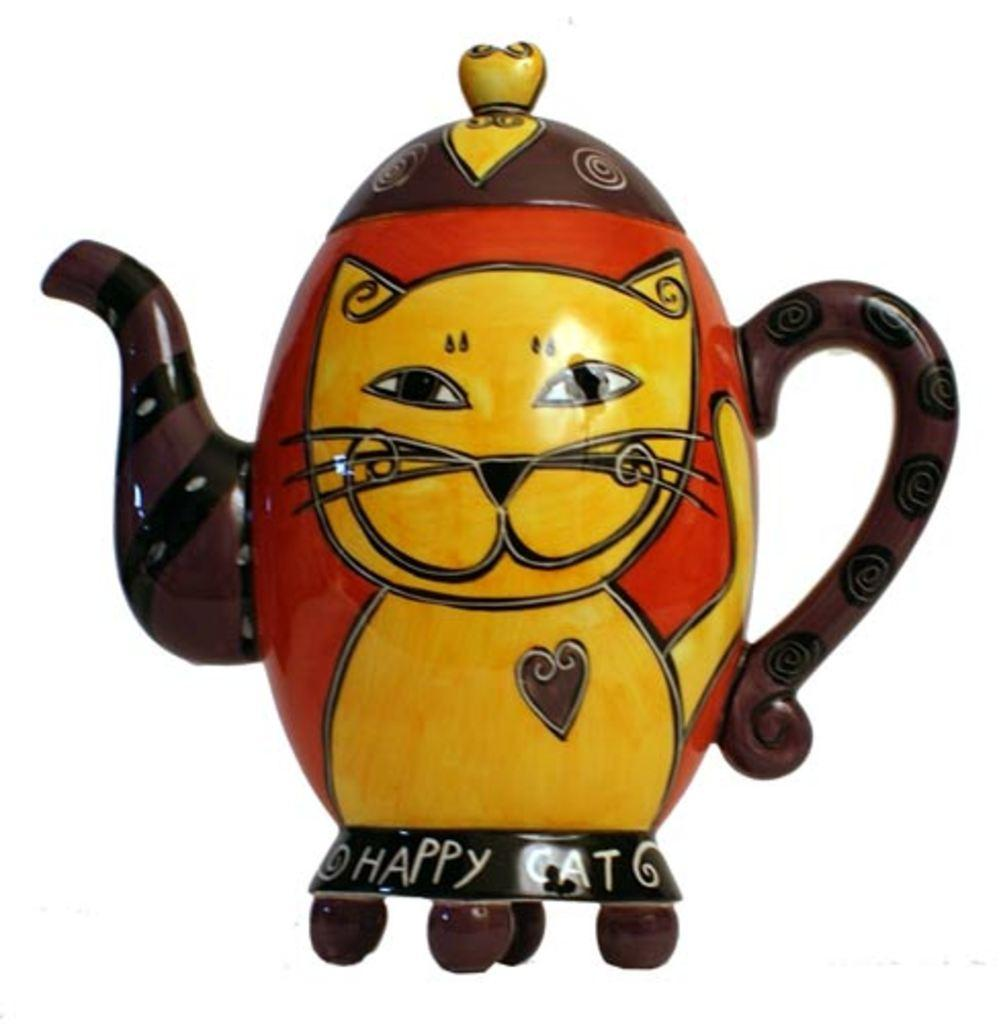What is the main object in the image? There is a kettle in the image. What type of hammer is being used to feed the pig in the image? There is no hammer or pig present in the image; it only features a kettle. 